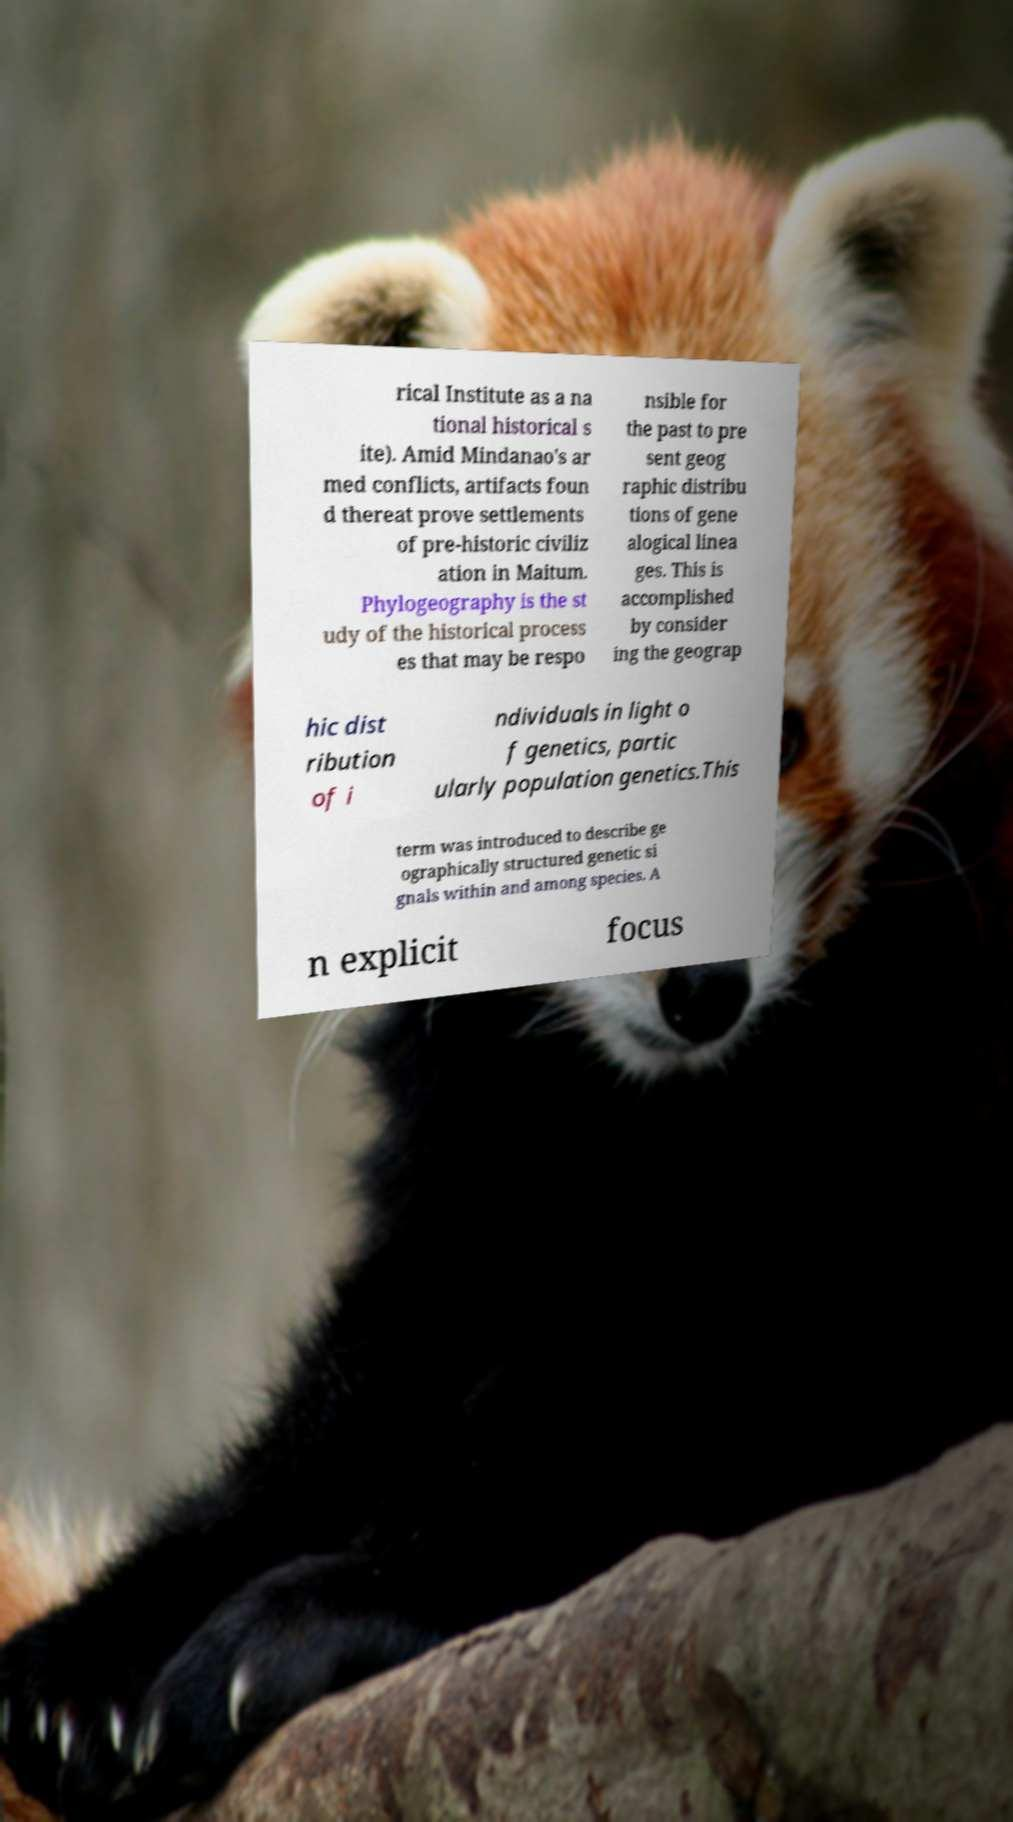There's text embedded in this image that I need extracted. Can you transcribe it verbatim? rical Institute as a na tional historical s ite). Amid Mindanao's ar med conflicts, artifacts foun d thereat prove settlements of pre-historic civiliz ation in Maitum. Phylogeography is the st udy of the historical process es that may be respo nsible for the past to pre sent geog raphic distribu tions of gene alogical linea ges. This is accomplished by consider ing the geograp hic dist ribution of i ndividuals in light o f genetics, partic ularly population genetics.This term was introduced to describe ge ographically structured genetic si gnals within and among species. A n explicit focus 